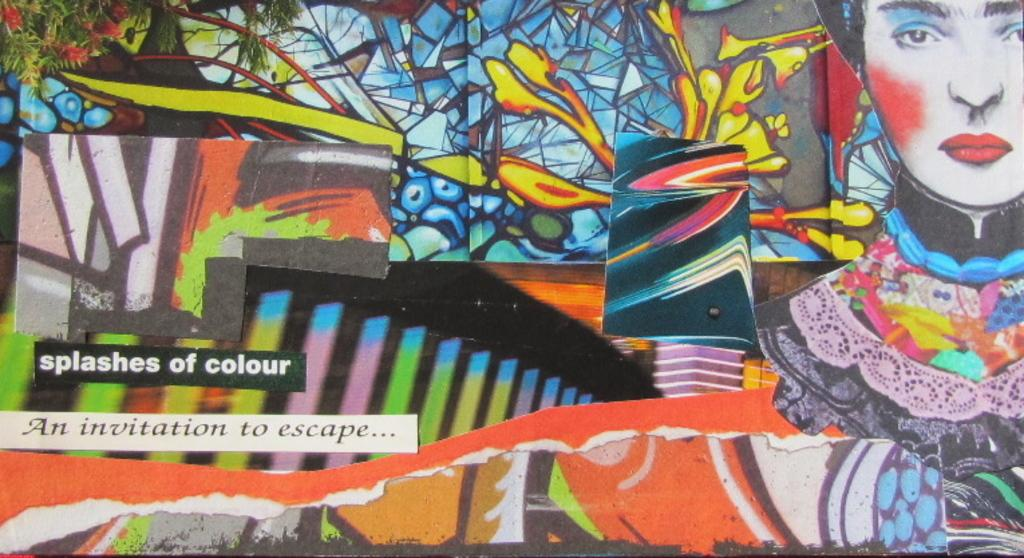What is present on the wall in the image? There is graffiti and writing on the wall in the image. Can you describe the graffiti on the wall? Unfortunately, the specific details of the graffiti cannot be determined from the provided facts. What type of writing is present on the wall? The type of writing on the wall cannot be determined from the provided facts. Can you tell me what verse the monkey is reciting in the image? There is no monkey present in the image, and therefore no verse can be attributed to it. 